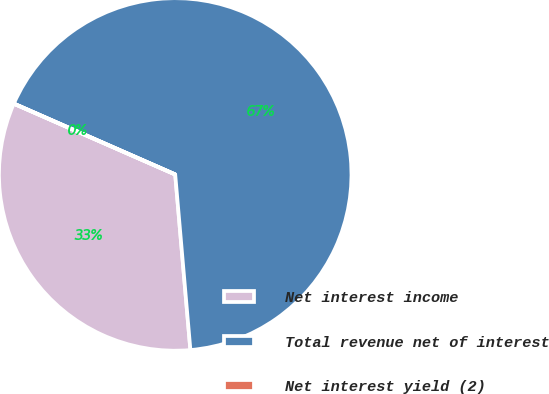Convert chart. <chart><loc_0><loc_0><loc_500><loc_500><pie_chart><fcel>Net interest income<fcel>Total revenue net of interest<fcel>Net interest yield (2)<nl><fcel>32.95%<fcel>67.04%<fcel>0.01%<nl></chart> 